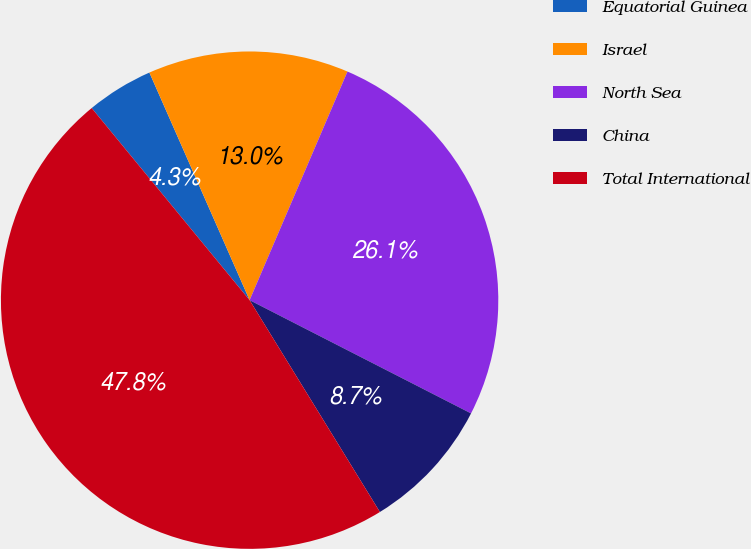Convert chart. <chart><loc_0><loc_0><loc_500><loc_500><pie_chart><fcel>Equatorial Guinea<fcel>Israel<fcel>North Sea<fcel>China<fcel>Total International<nl><fcel>4.35%<fcel>13.04%<fcel>26.09%<fcel>8.7%<fcel>47.83%<nl></chart> 